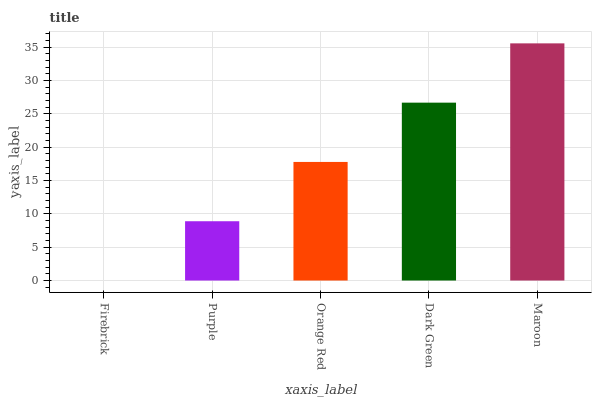Is Firebrick the minimum?
Answer yes or no. Yes. Is Maroon the maximum?
Answer yes or no. Yes. Is Purple the minimum?
Answer yes or no. No. Is Purple the maximum?
Answer yes or no. No. Is Purple greater than Firebrick?
Answer yes or no. Yes. Is Firebrick less than Purple?
Answer yes or no. Yes. Is Firebrick greater than Purple?
Answer yes or no. No. Is Purple less than Firebrick?
Answer yes or no. No. Is Orange Red the high median?
Answer yes or no. Yes. Is Orange Red the low median?
Answer yes or no. Yes. Is Dark Green the high median?
Answer yes or no. No. Is Maroon the low median?
Answer yes or no. No. 